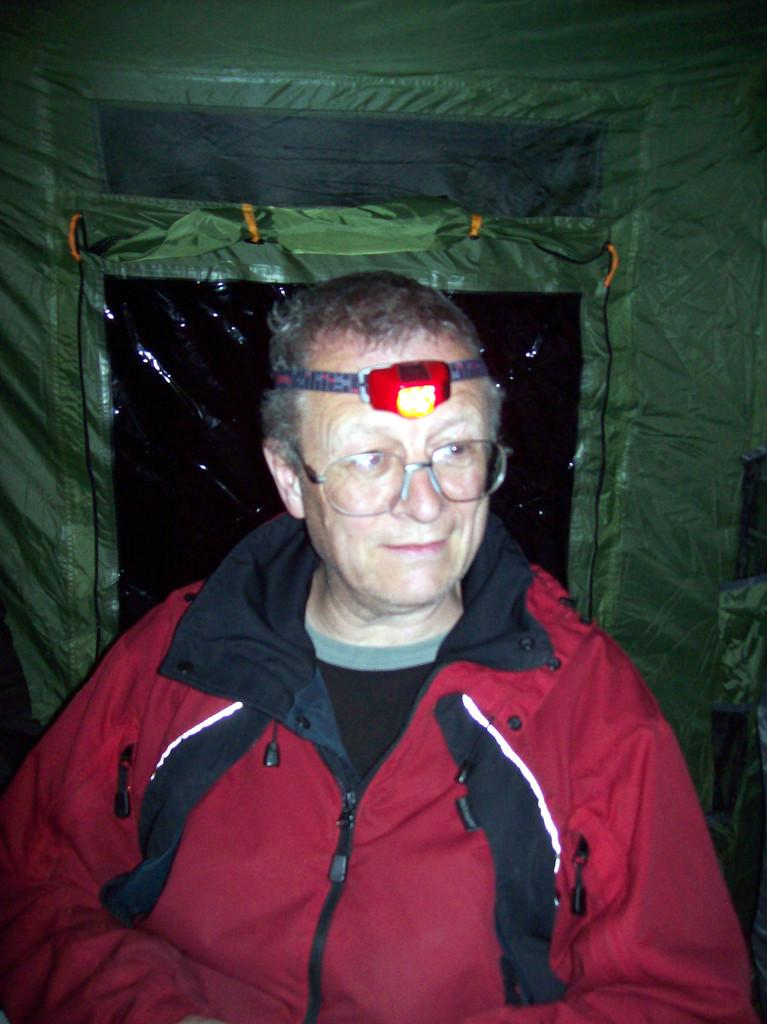Who is the main subject in the image? There is an old man in the image. What is the old man wearing? The old man is wearing a red jacket. Where is the old man located in the image? The old man is in front of the image. What is the setting of the image? The old man is inside a tent. What is the old man holding or wearing on his head? The old man has a torch on his head. What type of building can be seen in the image? There is no building present in the image; it features an old man inside a tent. What curve can be observed in the image? There is no curve present in the image; it features an old man inside a tent with a torch on his head. 